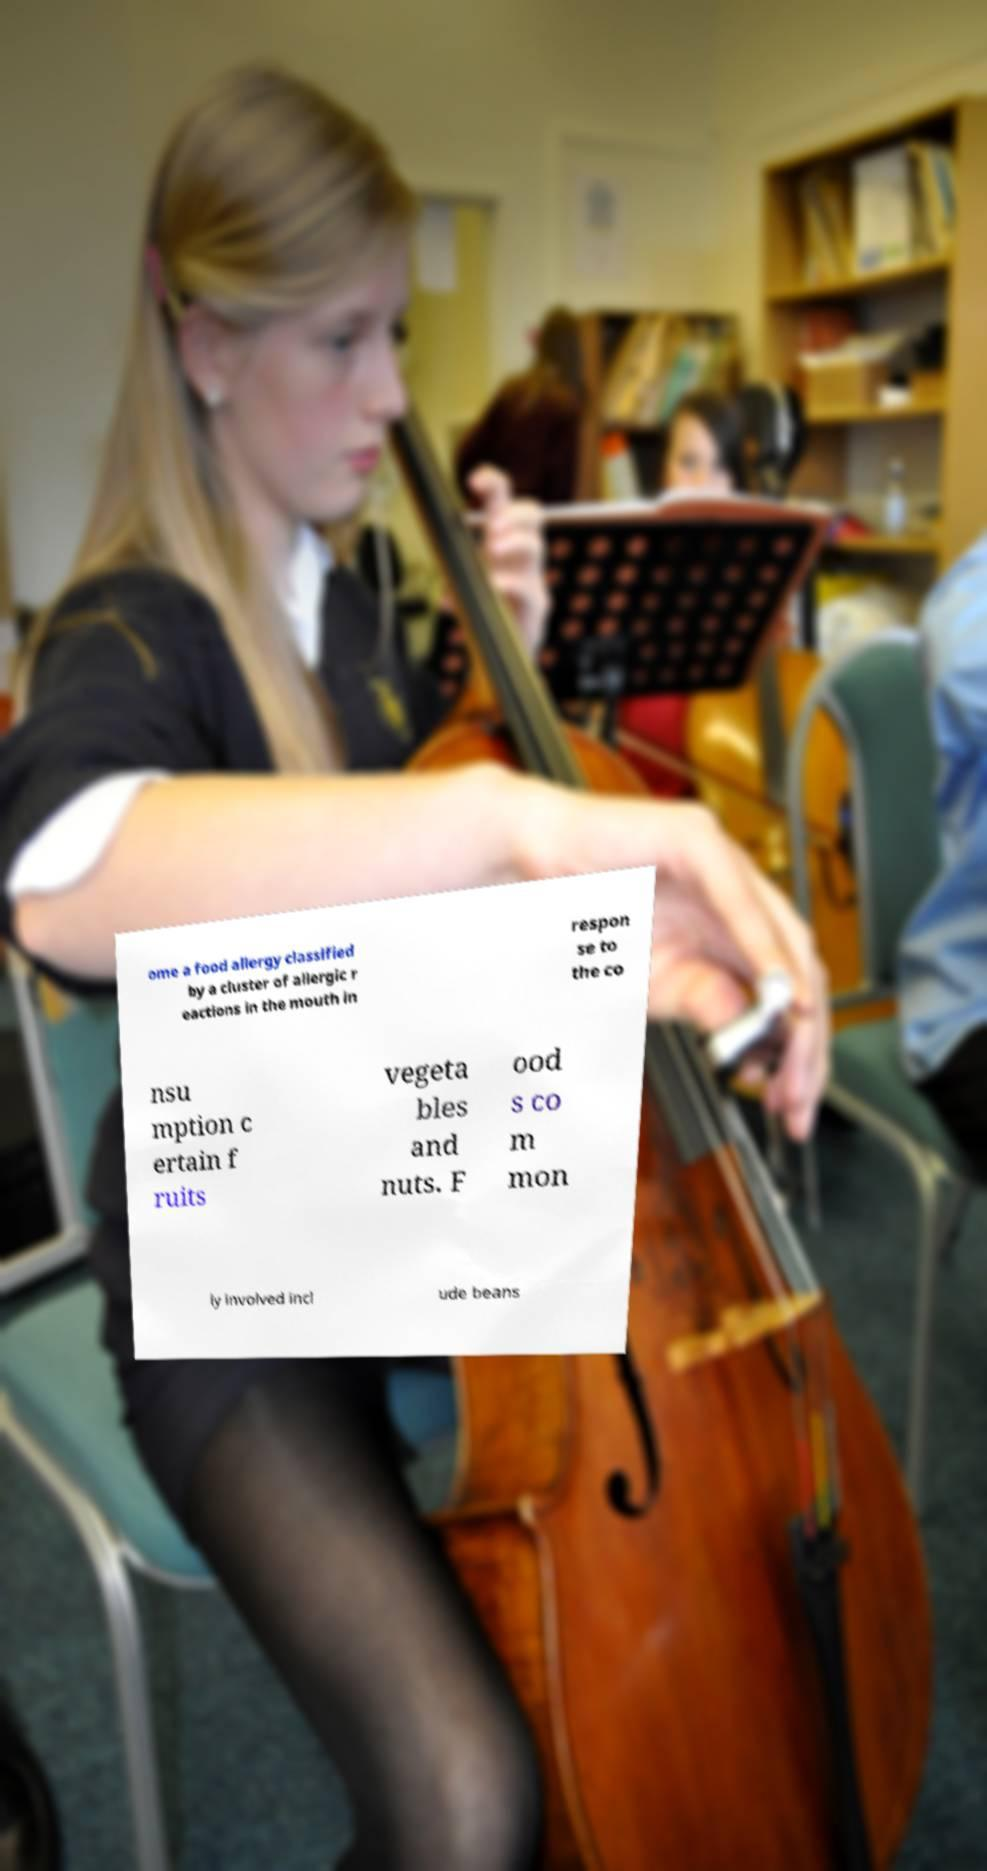Can you accurately transcribe the text from the provided image for me? ome a food allergy classified by a cluster of allergic r eactions in the mouth in respon se to the co nsu mption c ertain f ruits vegeta bles and nuts. F ood s co m mon ly involved incl ude beans 